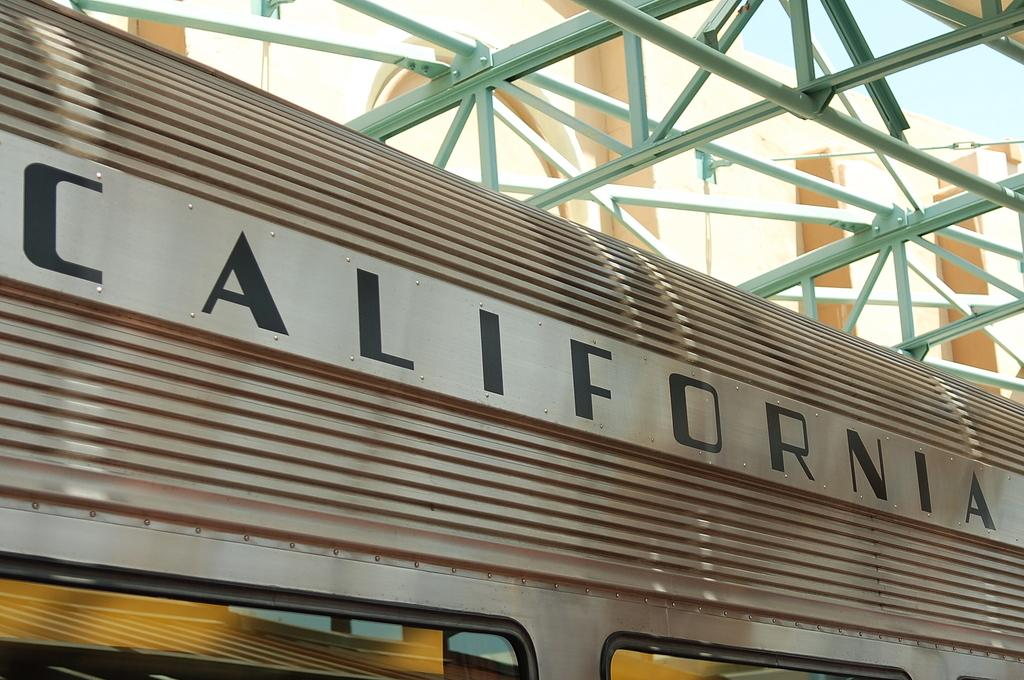What is the main subject of the image? The image appears to depict a train. Can you describe any text visible on the train? Yes, there is text visible on the train. What other structures or objects can be seen in the image? There is a building in the image. How would you describe the sky in the image? The sky is blue and cloudy in the image. What type of iron is being used to maintain the sidewalk in the image? There is no iron or sidewalk present in the image; it features a train and a building. How does the train show respect to the passengers in the image? The image does not depict any interaction between the train and passengers, nor does it show any indication of respect. 